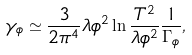<formula> <loc_0><loc_0><loc_500><loc_500>\gamma _ { \phi } \simeq \frac { 3 } { 2 \pi ^ { 4 } } \lambda \phi ^ { 2 } \ln \frac { T ^ { 2 } } { \lambda \phi ^ { 2 } } \frac { 1 } { \Gamma _ { \phi } } ,</formula> 